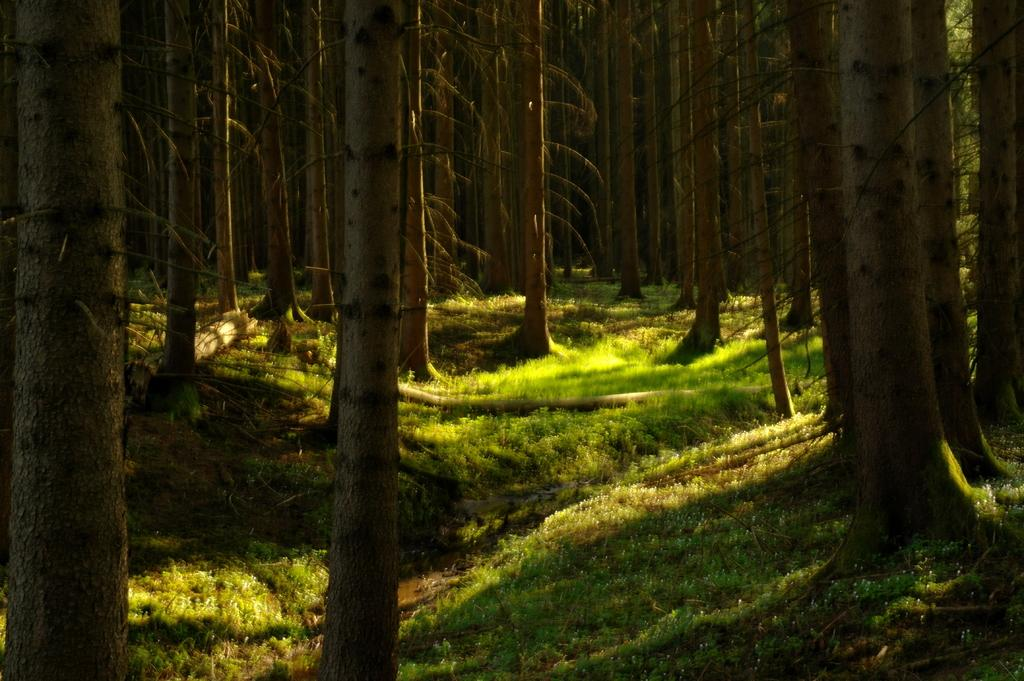What type of vegetation can be seen in the image? There are trees in the image. What else can be seen on the ground in the image? There is grass in the image. Reasoning: Let's think step by identifying the main subjects in the image based on the provided facts. We start by mentioning the trees, which are the first fact given. Then, we include the grass, which is the second fact. We formulate questions that focus on the types of vegetation present in the image, ensuring that each question can be answered definitively with the information given. We avoid yes/no questions and ensure that the language is simple and clear. Absurd Question/Answer: What route do the children take to reach the ship in the image? There are no children or ship present in the image; it only features trees and grass. 